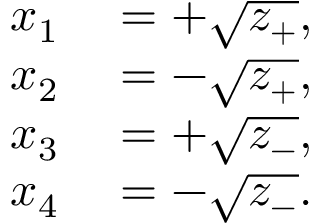<formula> <loc_0><loc_0><loc_500><loc_500>\begin{array} { r l } { x _ { 1 } } & = + { \sqrt { z _ { + } } } , } \\ { x _ { 2 } } & = - { \sqrt { z _ { + } } } , } \\ { x _ { 3 } } & = + { \sqrt { z _ { - } } } , } \\ { x _ { 4 } } & = - { \sqrt { z _ { - } } } . } \end{array}</formula> 